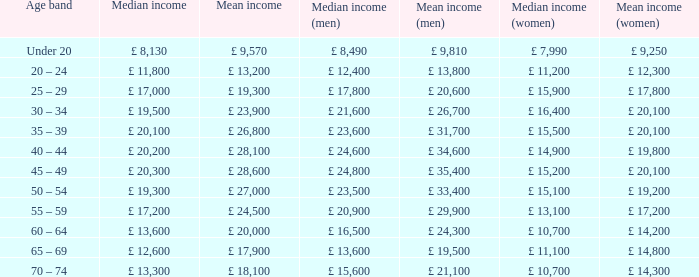Give me the full table as a dictionary. {'header': ['Age band', 'Median income', 'Mean income', 'Median income (men)', 'Mean income (men)', 'Median income (women)', 'Mean income (women)'], 'rows': [['Under 20', '£ 8,130', '£ 9,570', '£ 8,490', '£ 9,810', '£ 7,990', '£ 9,250'], ['20 – 24', '£ 11,800', '£ 13,200', '£ 12,400', '£ 13,800', '£ 11,200', '£ 12,300'], ['25 – 29', '£ 17,000', '£ 19,300', '£ 17,800', '£ 20,600', '£ 15,900', '£ 17,800'], ['30 – 34', '£ 19,500', '£ 23,900', '£ 21,600', '£ 26,700', '£ 16,400', '£ 20,100'], ['35 – 39', '£ 20,100', '£ 26,800', '£ 23,600', '£ 31,700', '£ 15,500', '£ 20,100'], ['40 – 44', '£ 20,200', '£ 28,100', '£ 24,600', '£ 34,600', '£ 14,900', '£ 19,800'], ['45 – 49', '£ 20,300', '£ 28,600', '£ 24,800', '£ 35,400', '£ 15,200', '£ 20,100'], ['50 – 54', '£ 19,300', '£ 27,000', '£ 23,500', '£ 33,400', '£ 15,100', '£ 19,200'], ['55 – 59', '£ 17,200', '£ 24,500', '£ 20,900', '£ 29,900', '£ 13,100', '£ 17,200'], ['60 – 64', '£ 13,600', '£ 20,000', '£ 16,500', '£ 24,300', '£ 10,700', '£ 14,200'], ['65 – 69', '£ 12,600', '£ 17,900', '£ 13,600', '£ 19,500', '£ 11,100', '£ 14,800'], ['70 – 74', '£ 13,300', '£ 18,100', '£ 15,600', '£ 21,100', '£ 10,700', '£ 14,300']]} What is the average income for the age group below 20? £ 8,130. 